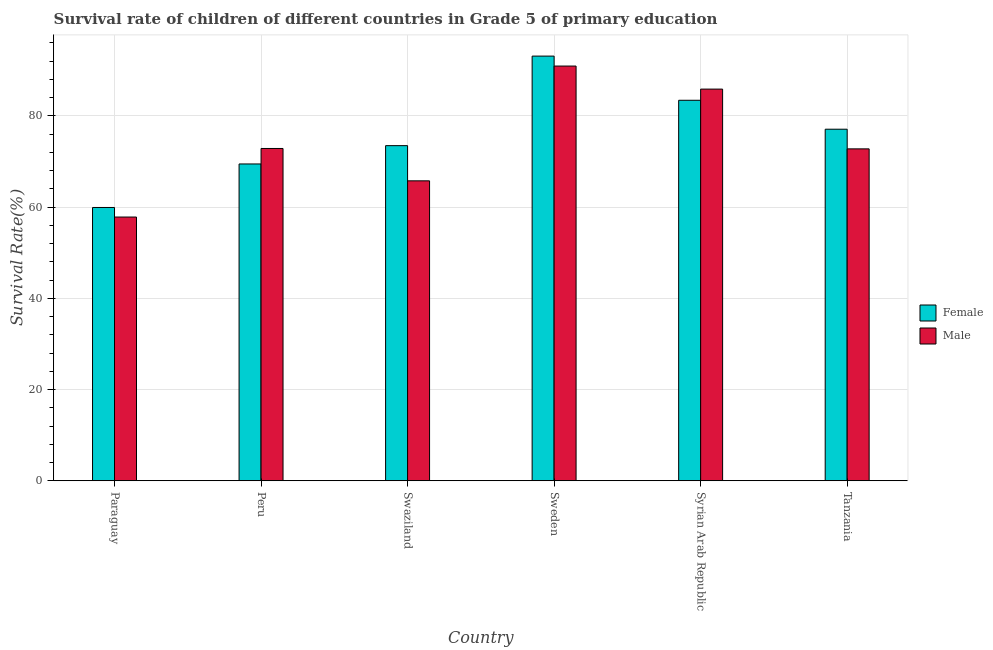How many groups of bars are there?
Offer a very short reply. 6. Are the number of bars on each tick of the X-axis equal?
Make the answer very short. Yes. How many bars are there on the 4th tick from the left?
Offer a very short reply. 2. How many bars are there on the 3rd tick from the right?
Provide a short and direct response. 2. What is the label of the 3rd group of bars from the left?
Provide a succinct answer. Swaziland. In how many cases, is the number of bars for a given country not equal to the number of legend labels?
Offer a very short reply. 0. What is the survival rate of male students in primary education in Sweden?
Make the answer very short. 90.9. Across all countries, what is the maximum survival rate of male students in primary education?
Ensure brevity in your answer.  90.9. Across all countries, what is the minimum survival rate of female students in primary education?
Make the answer very short. 59.9. In which country was the survival rate of female students in primary education maximum?
Ensure brevity in your answer.  Sweden. In which country was the survival rate of male students in primary education minimum?
Ensure brevity in your answer.  Paraguay. What is the total survival rate of female students in primary education in the graph?
Your answer should be compact. 456.33. What is the difference between the survival rate of male students in primary education in Peru and that in Syrian Arab Republic?
Your answer should be very brief. -13.01. What is the difference between the survival rate of female students in primary education in Paraguay and the survival rate of male students in primary education in Peru?
Offer a terse response. -12.93. What is the average survival rate of male students in primary education per country?
Make the answer very short. 74.31. What is the difference between the survival rate of female students in primary education and survival rate of male students in primary education in Paraguay?
Offer a terse response. 2.1. What is the ratio of the survival rate of female students in primary education in Peru to that in Tanzania?
Keep it short and to the point. 0.9. Is the difference between the survival rate of female students in primary education in Paraguay and Peru greater than the difference between the survival rate of male students in primary education in Paraguay and Peru?
Make the answer very short. Yes. What is the difference between the highest and the second highest survival rate of male students in primary education?
Your answer should be very brief. 5.05. What is the difference between the highest and the lowest survival rate of male students in primary education?
Offer a terse response. 33.09. In how many countries, is the survival rate of female students in primary education greater than the average survival rate of female students in primary education taken over all countries?
Ensure brevity in your answer.  3. Is the sum of the survival rate of male students in primary education in Peru and Swaziland greater than the maximum survival rate of female students in primary education across all countries?
Give a very brief answer. Yes. What does the 2nd bar from the right in Peru represents?
Provide a short and direct response. Female. How many bars are there?
Provide a short and direct response. 12. Are all the bars in the graph horizontal?
Keep it short and to the point. No. Are the values on the major ticks of Y-axis written in scientific E-notation?
Offer a terse response. No. Does the graph contain any zero values?
Your response must be concise. No. Does the graph contain grids?
Your answer should be very brief. Yes. Where does the legend appear in the graph?
Give a very brief answer. Center right. What is the title of the graph?
Your answer should be very brief. Survival rate of children of different countries in Grade 5 of primary education. Does "Fertility rate" appear as one of the legend labels in the graph?
Your answer should be very brief. No. What is the label or title of the X-axis?
Ensure brevity in your answer.  Country. What is the label or title of the Y-axis?
Offer a terse response. Survival Rate(%). What is the Survival Rate(%) of Female in Paraguay?
Your response must be concise. 59.9. What is the Survival Rate(%) in Male in Paraguay?
Give a very brief answer. 57.81. What is the Survival Rate(%) of Female in Peru?
Provide a succinct answer. 69.44. What is the Survival Rate(%) of Male in Peru?
Offer a very short reply. 72.83. What is the Survival Rate(%) in Female in Swaziland?
Your response must be concise. 73.45. What is the Survival Rate(%) of Male in Swaziland?
Your response must be concise. 65.74. What is the Survival Rate(%) in Female in Sweden?
Your answer should be very brief. 93.08. What is the Survival Rate(%) of Male in Sweden?
Your answer should be very brief. 90.9. What is the Survival Rate(%) of Female in Syrian Arab Republic?
Make the answer very short. 83.4. What is the Survival Rate(%) of Male in Syrian Arab Republic?
Ensure brevity in your answer.  85.85. What is the Survival Rate(%) of Female in Tanzania?
Give a very brief answer. 77.06. What is the Survival Rate(%) of Male in Tanzania?
Your answer should be very brief. 72.75. Across all countries, what is the maximum Survival Rate(%) in Female?
Ensure brevity in your answer.  93.08. Across all countries, what is the maximum Survival Rate(%) of Male?
Your answer should be compact. 90.9. Across all countries, what is the minimum Survival Rate(%) of Female?
Provide a short and direct response. 59.9. Across all countries, what is the minimum Survival Rate(%) of Male?
Provide a succinct answer. 57.81. What is the total Survival Rate(%) in Female in the graph?
Ensure brevity in your answer.  456.33. What is the total Survival Rate(%) in Male in the graph?
Your answer should be compact. 445.88. What is the difference between the Survival Rate(%) of Female in Paraguay and that in Peru?
Offer a terse response. -9.54. What is the difference between the Survival Rate(%) in Male in Paraguay and that in Peru?
Offer a very short reply. -15.03. What is the difference between the Survival Rate(%) of Female in Paraguay and that in Swaziland?
Keep it short and to the point. -13.55. What is the difference between the Survival Rate(%) in Male in Paraguay and that in Swaziland?
Offer a very short reply. -7.94. What is the difference between the Survival Rate(%) in Female in Paraguay and that in Sweden?
Offer a very short reply. -33.18. What is the difference between the Survival Rate(%) of Male in Paraguay and that in Sweden?
Your answer should be compact. -33.09. What is the difference between the Survival Rate(%) of Female in Paraguay and that in Syrian Arab Republic?
Keep it short and to the point. -23.5. What is the difference between the Survival Rate(%) in Male in Paraguay and that in Syrian Arab Republic?
Give a very brief answer. -28.04. What is the difference between the Survival Rate(%) in Female in Paraguay and that in Tanzania?
Give a very brief answer. -17.15. What is the difference between the Survival Rate(%) of Male in Paraguay and that in Tanzania?
Provide a short and direct response. -14.94. What is the difference between the Survival Rate(%) in Female in Peru and that in Swaziland?
Offer a terse response. -4.01. What is the difference between the Survival Rate(%) in Male in Peru and that in Swaziland?
Your answer should be compact. 7.09. What is the difference between the Survival Rate(%) of Female in Peru and that in Sweden?
Offer a terse response. -23.64. What is the difference between the Survival Rate(%) of Male in Peru and that in Sweden?
Your answer should be compact. -18.07. What is the difference between the Survival Rate(%) of Female in Peru and that in Syrian Arab Republic?
Provide a succinct answer. -13.96. What is the difference between the Survival Rate(%) of Male in Peru and that in Syrian Arab Republic?
Your response must be concise. -13.01. What is the difference between the Survival Rate(%) of Female in Peru and that in Tanzania?
Provide a short and direct response. -7.62. What is the difference between the Survival Rate(%) of Male in Peru and that in Tanzania?
Provide a short and direct response. 0.09. What is the difference between the Survival Rate(%) in Female in Swaziland and that in Sweden?
Offer a terse response. -19.63. What is the difference between the Survival Rate(%) in Male in Swaziland and that in Sweden?
Your answer should be compact. -25.16. What is the difference between the Survival Rate(%) of Female in Swaziland and that in Syrian Arab Republic?
Offer a very short reply. -9.95. What is the difference between the Survival Rate(%) in Male in Swaziland and that in Syrian Arab Republic?
Your answer should be compact. -20.11. What is the difference between the Survival Rate(%) in Female in Swaziland and that in Tanzania?
Offer a very short reply. -3.6. What is the difference between the Survival Rate(%) in Male in Swaziland and that in Tanzania?
Keep it short and to the point. -7.01. What is the difference between the Survival Rate(%) of Female in Sweden and that in Syrian Arab Republic?
Provide a short and direct response. 9.68. What is the difference between the Survival Rate(%) of Male in Sweden and that in Syrian Arab Republic?
Offer a terse response. 5.05. What is the difference between the Survival Rate(%) in Female in Sweden and that in Tanzania?
Give a very brief answer. 16.02. What is the difference between the Survival Rate(%) in Male in Sweden and that in Tanzania?
Offer a terse response. 18.15. What is the difference between the Survival Rate(%) in Female in Syrian Arab Republic and that in Tanzania?
Your response must be concise. 6.34. What is the difference between the Survival Rate(%) of Male in Syrian Arab Republic and that in Tanzania?
Ensure brevity in your answer.  13.1. What is the difference between the Survival Rate(%) of Female in Paraguay and the Survival Rate(%) of Male in Peru?
Provide a succinct answer. -12.93. What is the difference between the Survival Rate(%) in Female in Paraguay and the Survival Rate(%) in Male in Swaziland?
Keep it short and to the point. -5.84. What is the difference between the Survival Rate(%) in Female in Paraguay and the Survival Rate(%) in Male in Sweden?
Offer a very short reply. -31. What is the difference between the Survival Rate(%) in Female in Paraguay and the Survival Rate(%) in Male in Syrian Arab Republic?
Provide a succinct answer. -25.94. What is the difference between the Survival Rate(%) in Female in Paraguay and the Survival Rate(%) in Male in Tanzania?
Provide a succinct answer. -12.85. What is the difference between the Survival Rate(%) in Female in Peru and the Survival Rate(%) in Male in Swaziland?
Give a very brief answer. 3.7. What is the difference between the Survival Rate(%) in Female in Peru and the Survival Rate(%) in Male in Sweden?
Your answer should be very brief. -21.46. What is the difference between the Survival Rate(%) of Female in Peru and the Survival Rate(%) of Male in Syrian Arab Republic?
Your answer should be very brief. -16.41. What is the difference between the Survival Rate(%) of Female in Peru and the Survival Rate(%) of Male in Tanzania?
Keep it short and to the point. -3.31. What is the difference between the Survival Rate(%) of Female in Swaziland and the Survival Rate(%) of Male in Sweden?
Keep it short and to the point. -17.45. What is the difference between the Survival Rate(%) in Female in Swaziland and the Survival Rate(%) in Male in Syrian Arab Republic?
Offer a very short reply. -12.39. What is the difference between the Survival Rate(%) in Female in Swaziland and the Survival Rate(%) in Male in Tanzania?
Your answer should be compact. 0.7. What is the difference between the Survival Rate(%) in Female in Sweden and the Survival Rate(%) in Male in Syrian Arab Republic?
Keep it short and to the point. 7.23. What is the difference between the Survival Rate(%) of Female in Sweden and the Survival Rate(%) of Male in Tanzania?
Make the answer very short. 20.33. What is the difference between the Survival Rate(%) of Female in Syrian Arab Republic and the Survival Rate(%) of Male in Tanzania?
Make the answer very short. 10.65. What is the average Survival Rate(%) of Female per country?
Give a very brief answer. 76.06. What is the average Survival Rate(%) in Male per country?
Offer a terse response. 74.31. What is the difference between the Survival Rate(%) of Female and Survival Rate(%) of Male in Paraguay?
Keep it short and to the point. 2.1. What is the difference between the Survival Rate(%) in Female and Survival Rate(%) in Male in Peru?
Give a very brief answer. -3.39. What is the difference between the Survival Rate(%) in Female and Survival Rate(%) in Male in Swaziland?
Your response must be concise. 7.71. What is the difference between the Survival Rate(%) in Female and Survival Rate(%) in Male in Sweden?
Give a very brief answer. 2.18. What is the difference between the Survival Rate(%) of Female and Survival Rate(%) of Male in Syrian Arab Republic?
Your answer should be compact. -2.45. What is the difference between the Survival Rate(%) of Female and Survival Rate(%) of Male in Tanzania?
Your answer should be very brief. 4.31. What is the ratio of the Survival Rate(%) in Female in Paraguay to that in Peru?
Offer a terse response. 0.86. What is the ratio of the Survival Rate(%) in Male in Paraguay to that in Peru?
Provide a short and direct response. 0.79. What is the ratio of the Survival Rate(%) in Female in Paraguay to that in Swaziland?
Provide a short and direct response. 0.82. What is the ratio of the Survival Rate(%) in Male in Paraguay to that in Swaziland?
Keep it short and to the point. 0.88. What is the ratio of the Survival Rate(%) of Female in Paraguay to that in Sweden?
Offer a terse response. 0.64. What is the ratio of the Survival Rate(%) of Male in Paraguay to that in Sweden?
Your response must be concise. 0.64. What is the ratio of the Survival Rate(%) in Female in Paraguay to that in Syrian Arab Republic?
Your response must be concise. 0.72. What is the ratio of the Survival Rate(%) in Male in Paraguay to that in Syrian Arab Republic?
Your answer should be very brief. 0.67. What is the ratio of the Survival Rate(%) in Female in Paraguay to that in Tanzania?
Keep it short and to the point. 0.78. What is the ratio of the Survival Rate(%) in Male in Paraguay to that in Tanzania?
Ensure brevity in your answer.  0.79. What is the ratio of the Survival Rate(%) of Female in Peru to that in Swaziland?
Make the answer very short. 0.95. What is the ratio of the Survival Rate(%) in Male in Peru to that in Swaziland?
Keep it short and to the point. 1.11. What is the ratio of the Survival Rate(%) in Female in Peru to that in Sweden?
Provide a succinct answer. 0.75. What is the ratio of the Survival Rate(%) of Male in Peru to that in Sweden?
Your answer should be very brief. 0.8. What is the ratio of the Survival Rate(%) of Female in Peru to that in Syrian Arab Republic?
Your response must be concise. 0.83. What is the ratio of the Survival Rate(%) in Male in Peru to that in Syrian Arab Republic?
Provide a short and direct response. 0.85. What is the ratio of the Survival Rate(%) in Female in Peru to that in Tanzania?
Ensure brevity in your answer.  0.9. What is the ratio of the Survival Rate(%) in Male in Peru to that in Tanzania?
Make the answer very short. 1. What is the ratio of the Survival Rate(%) of Female in Swaziland to that in Sweden?
Make the answer very short. 0.79. What is the ratio of the Survival Rate(%) of Male in Swaziland to that in Sweden?
Offer a very short reply. 0.72. What is the ratio of the Survival Rate(%) in Female in Swaziland to that in Syrian Arab Republic?
Provide a succinct answer. 0.88. What is the ratio of the Survival Rate(%) in Male in Swaziland to that in Syrian Arab Republic?
Keep it short and to the point. 0.77. What is the ratio of the Survival Rate(%) in Female in Swaziland to that in Tanzania?
Ensure brevity in your answer.  0.95. What is the ratio of the Survival Rate(%) in Male in Swaziland to that in Tanzania?
Provide a succinct answer. 0.9. What is the ratio of the Survival Rate(%) in Female in Sweden to that in Syrian Arab Republic?
Your answer should be very brief. 1.12. What is the ratio of the Survival Rate(%) of Male in Sweden to that in Syrian Arab Republic?
Provide a succinct answer. 1.06. What is the ratio of the Survival Rate(%) in Female in Sweden to that in Tanzania?
Ensure brevity in your answer.  1.21. What is the ratio of the Survival Rate(%) in Male in Sweden to that in Tanzania?
Your answer should be very brief. 1.25. What is the ratio of the Survival Rate(%) in Female in Syrian Arab Republic to that in Tanzania?
Provide a short and direct response. 1.08. What is the ratio of the Survival Rate(%) of Male in Syrian Arab Republic to that in Tanzania?
Offer a very short reply. 1.18. What is the difference between the highest and the second highest Survival Rate(%) in Female?
Offer a terse response. 9.68. What is the difference between the highest and the second highest Survival Rate(%) of Male?
Offer a terse response. 5.05. What is the difference between the highest and the lowest Survival Rate(%) of Female?
Give a very brief answer. 33.18. What is the difference between the highest and the lowest Survival Rate(%) in Male?
Provide a short and direct response. 33.09. 